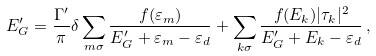Convert formula to latex. <formula><loc_0><loc_0><loc_500><loc_500>E _ { G } ^ { \prime } = \frac { \Gamma ^ { \prime } } { \pi } \delta \sum _ { m \sigma } \frac { f ( \varepsilon _ { m } ) } { E _ { G } ^ { \prime } + \varepsilon _ { m } - \varepsilon _ { d } } + \sum _ { k \sigma } \frac { f ( E _ { k } ) | \tau _ { k } | ^ { 2 } } { E _ { G } ^ { \prime } + E _ { k } - \varepsilon _ { d } } \, ,</formula> 